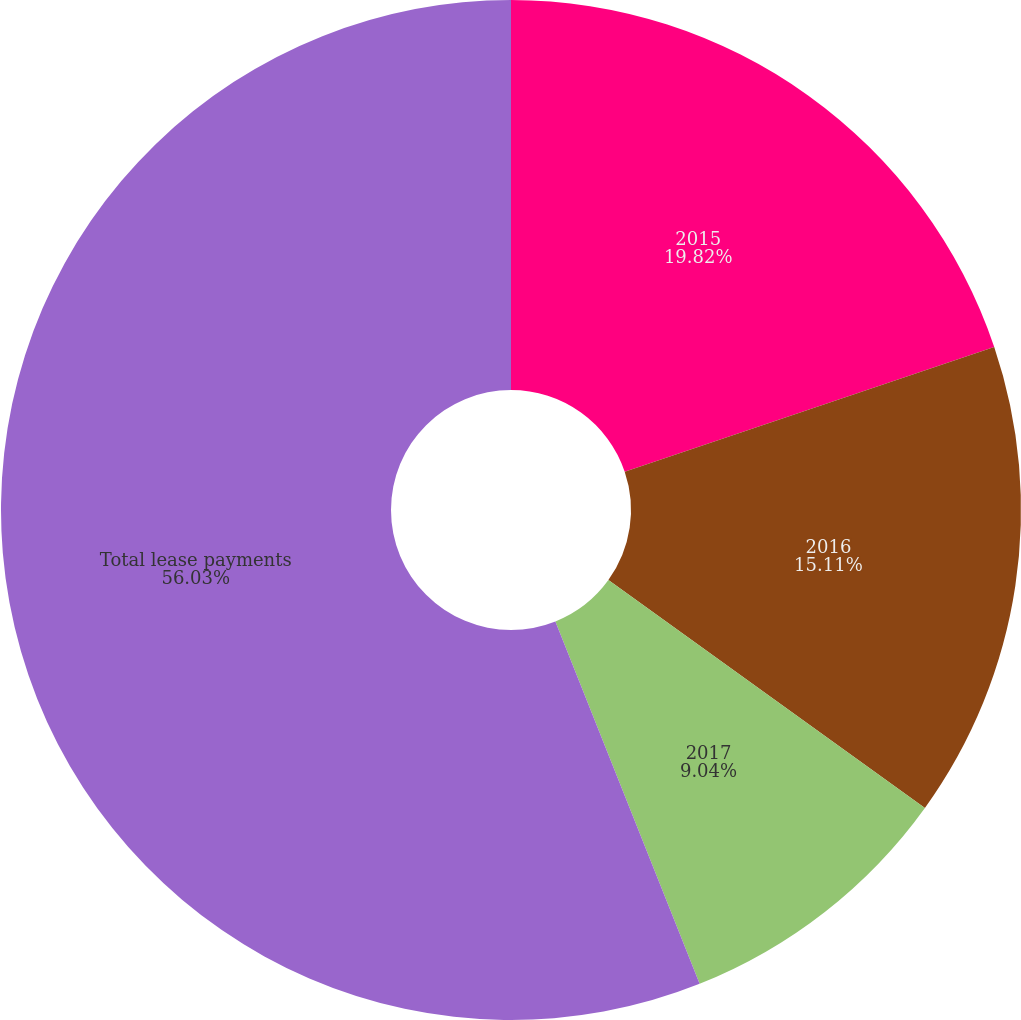Convert chart to OTSL. <chart><loc_0><loc_0><loc_500><loc_500><pie_chart><fcel>2015<fcel>2016<fcel>2017<fcel>Total lease payments<nl><fcel>19.82%<fcel>15.11%<fcel>9.04%<fcel>56.03%<nl></chart> 